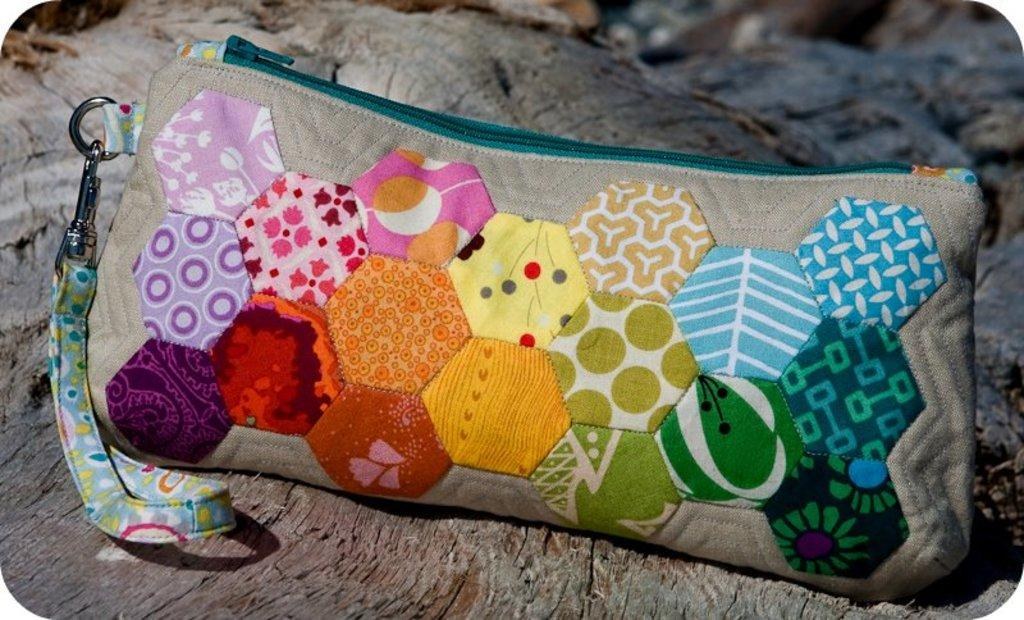What type of object is visible in the image? There is a zipper pouch in the image. Can you describe the location of the zipper pouch? The zipper pouch is on a surface. How many balls are visible in the image? There are no balls present in the image. What type of camera is being used to take the picture? There is no camera visible in the image, as it is focused on the zipper pouch. 